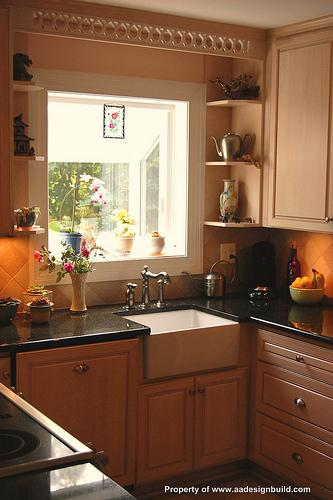Based on the objects in the image, speculate what kind of household this kitchen belongs to. This kitchen likely belongs to a household that values aesthetics and enjoys cooking, as evident by the variety of kitchenware, decorations, and items on display. What kind of sentiment does this image evoke? The image evokes a cozy and homey sentiment, with a well-decorated kitchen and various objects on display. Name the various objects found on the kitchen counter. A farm style kitchen sink, bowl of fruit, watering can, white apron sink, metal water jug, kettle, fake flower, white vase, bottle of wine, and black marble kitchen counter. Describe the state of the plant on the shelf and its surroundings. The plant on the shelf is wilting, and it is surrounded by a watering can, a teapot, and a sculpture. What kind of sink is in the image and which item is above it? There is a farm style kitchen sink and a large window in the kitchen above it. How many pieces of fruit are visible in the image? There are at least four pieces of fruit visible: bananas, orange, and other fruits in the bowl. Explain the interaction between the wilting plant and the watering can on the shelf. The wilting plant may not have been watered recently, and the watering can nearby could be used to hydrate the plant to revive it. Count the number of flowers displayed in the image. There are two vases of flowers displayed, one on the table and one on the window sill. 